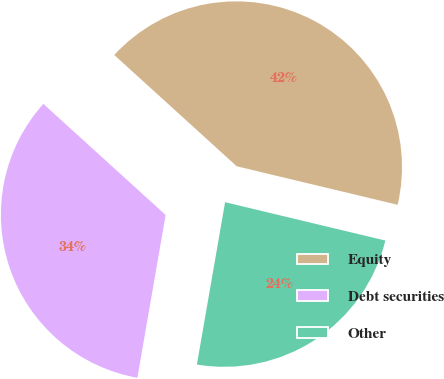Convert chart. <chart><loc_0><loc_0><loc_500><loc_500><pie_chart><fcel>Equity<fcel>Debt securities<fcel>Other<nl><fcel>42.0%<fcel>34.0%<fcel>24.0%<nl></chart> 